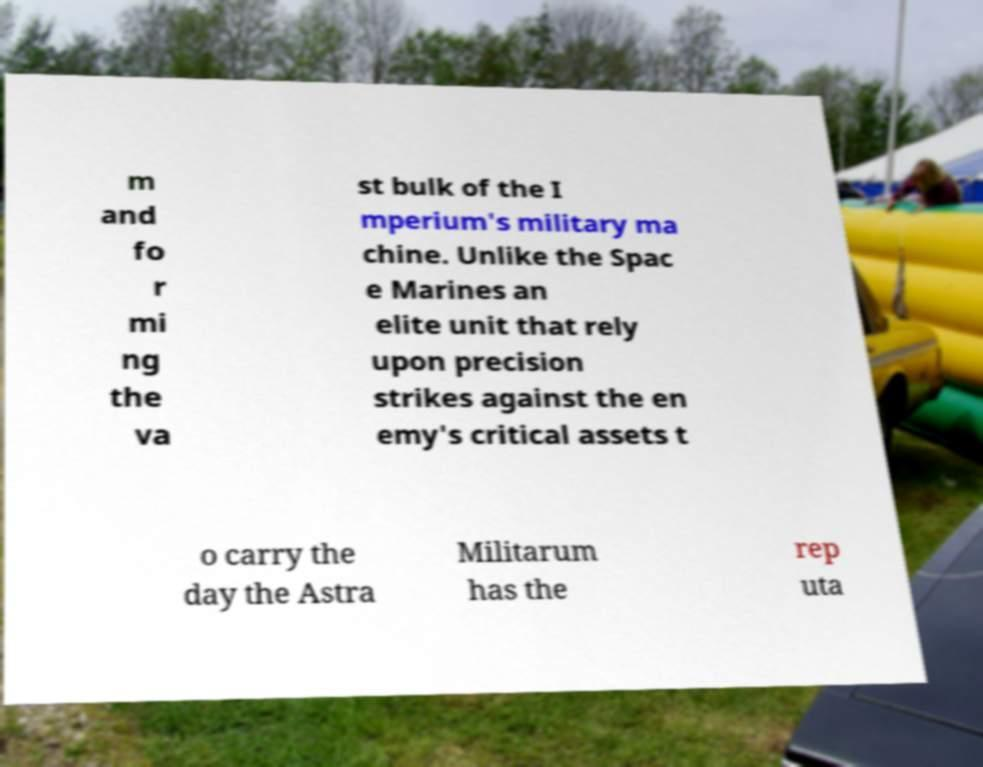Can you read and provide the text displayed in the image?This photo seems to have some interesting text. Can you extract and type it out for me? m and fo r mi ng the va st bulk of the I mperium's military ma chine. Unlike the Spac e Marines an elite unit that rely upon precision strikes against the en emy's critical assets t o carry the day the Astra Militarum has the rep uta 